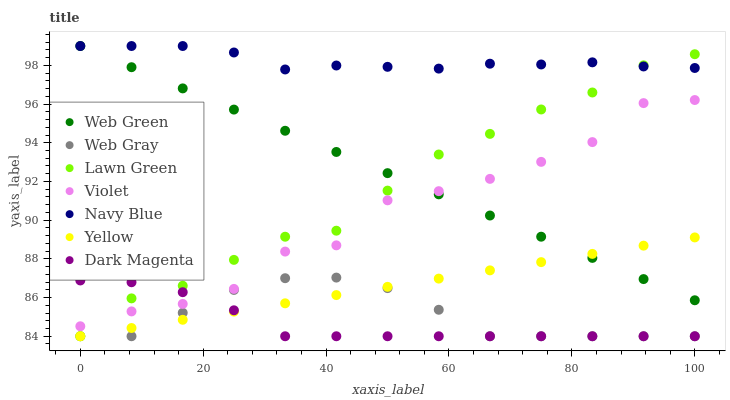Does Dark Magenta have the minimum area under the curve?
Answer yes or no. Yes. Does Navy Blue have the maximum area under the curve?
Answer yes or no. Yes. Does Web Gray have the minimum area under the curve?
Answer yes or no. No. Does Web Gray have the maximum area under the curve?
Answer yes or no. No. Is Yellow the smoothest?
Answer yes or no. Yes. Is Violet the roughest?
Answer yes or no. Yes. Is Web Gray the smoothest?
Answer yes or no. No. Is Web Gray the roughest?
Answer yes or no. No. Does Lawn Green have the lowest value?
Answer yes or no. Yes. Does Navy Blue have the lowest value?
Answer yes or no. No. Does Web Green have the highest value?
Answer yes or no. Yes. Does Web Gray have the highest value?
Answer yes or no. No. Is Yellow less than Navy Blue?
Answer yes or no. Yes. Is Navy Blue greater than Web Gray?
Answer yes or no. Yes. Does Navy Blue intersect Lawn Green?
Answer yes or no. Yes. Is Navy Blue less than Lawn Green?
Answer yes or no. No. Is Navy Blue greater than Lawn Green?
Answer yes or no. No. Does Yellow intersect Navy Blue?
Answer yes or no. No. 